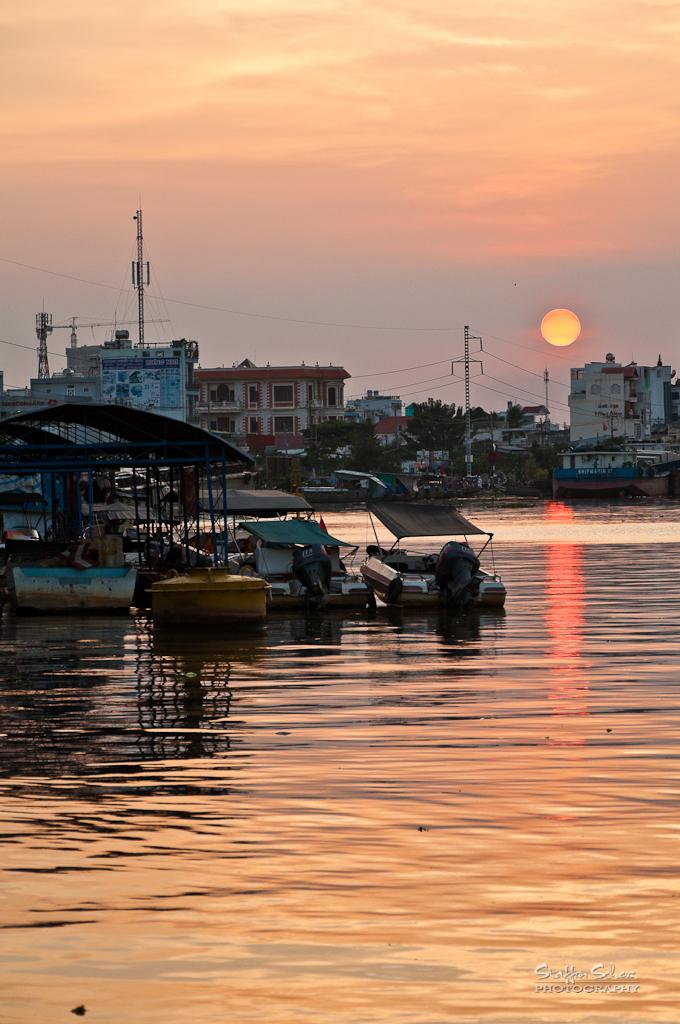What type of structures can be seen in the image? There are buildings in the image. What other objects can be seen in the image? There are poles, a crane tower, trees, boards, water, boats, and various unspecified "things." What is the weather like in the image? The sky is cloudy, but the sun is also visible in the image. Can you describe the water in the image? There is water visible in the image, and there are boats in the water. Is there any text or marking on the image? Yes, there is a watermark at the bottom right side of the image. What type of birds can be seen flying over the science lab in the image? There is no mention of birds or a science lab in the image. What type of cord is used to connect the various "things" in the image? The provided facts do not mention any cords or connections between the unspecified "things" in the image. 